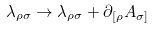<formula> <loc_0><loc_0><loc_500><loc_500>\lambda _ { \rho \sigma } \rightarrow \lambda _ { \rho \sigma } + \partial _ { [ \rho } A _ { \sigma ] }</formula> 